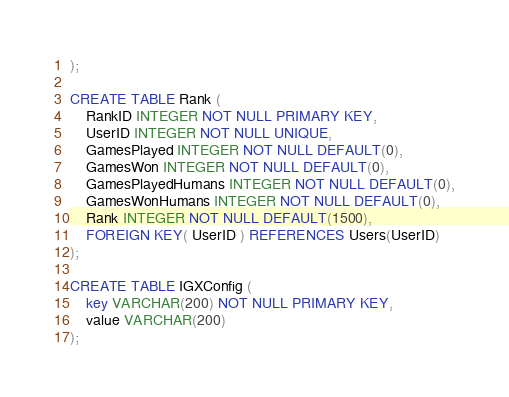<code> <loc_0><loc_0><loc_500><loc_500><_SQL_>);

CREATE TABLE Rank (
    RankID INTEGER NOT NULL PRIMARY KEY,
    UserID INTEGER NOT NULL UNIQUE,
    GamesPlayed INTEGER NOT NULL DEFAULT(0),
    GamesWon INTEGER NOT NULL DEFAULT(0),
    GamesPlayedHumans INTEGER NOT NULL DEFAULT(0),
    GamesWonHumans INTEGER NOT NULL DEFAULT(0),
    Rank INTEGER NOT NULL DEFAULT(1500),
    FOREIGN KEY( UserID ) REFERENCES Users(UserID)
);

CREATE TABLE IGXConfig (
    key VARCHAR(200) NOT NULL PRIMARY KEY,
    value VARCHAR(200)
);</code> 